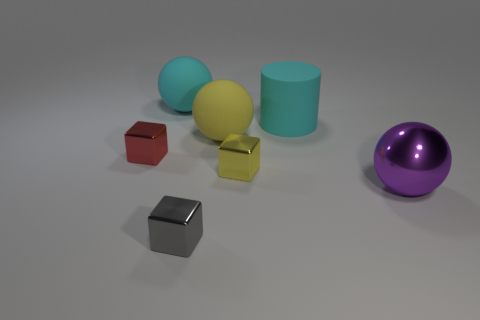Subtract all yellow cubes. Subtract all cyan balls. How many cubes are left? 2 Add 1 yellow balls. How many objects exist? 8 Subtract all cubes. How many objects are left? 4 Subtract 1 purple spheres. How many objects are left? 6 Subtract all cyan matte things. Subtract all red cubes. How many objects are left? 4 Add 3 small metal cubes. How many small metal cubes are left? 6 Add 1 cyan rubber balls. How many cyan rubber balls exist? 2 